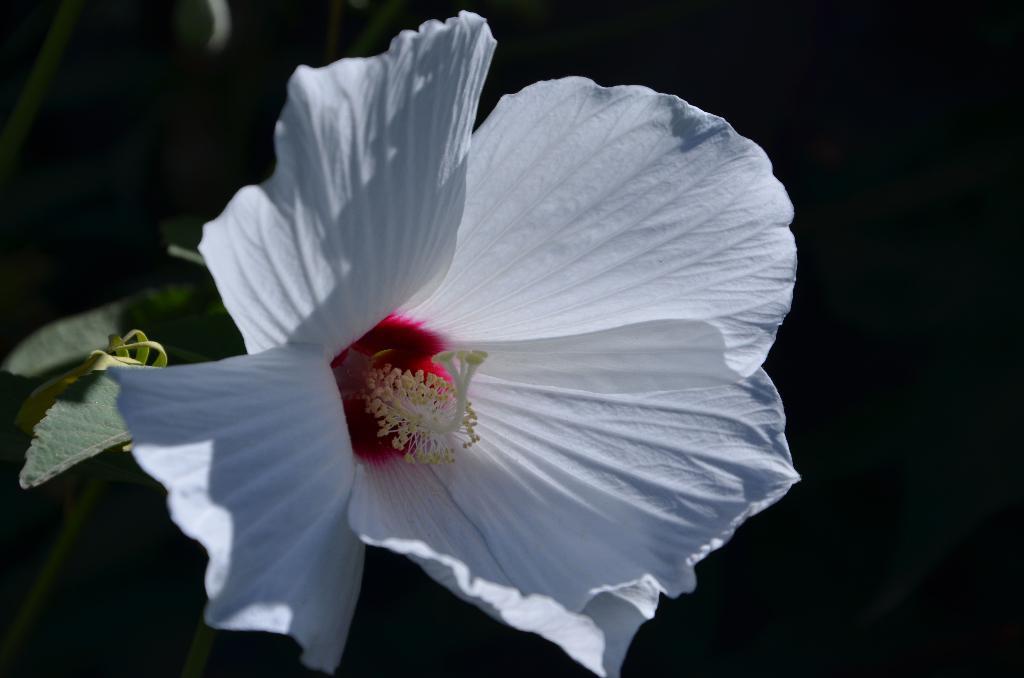Can you describe this image briefly? In this image, I can see a white flower and leaves. The background looks blurry. 